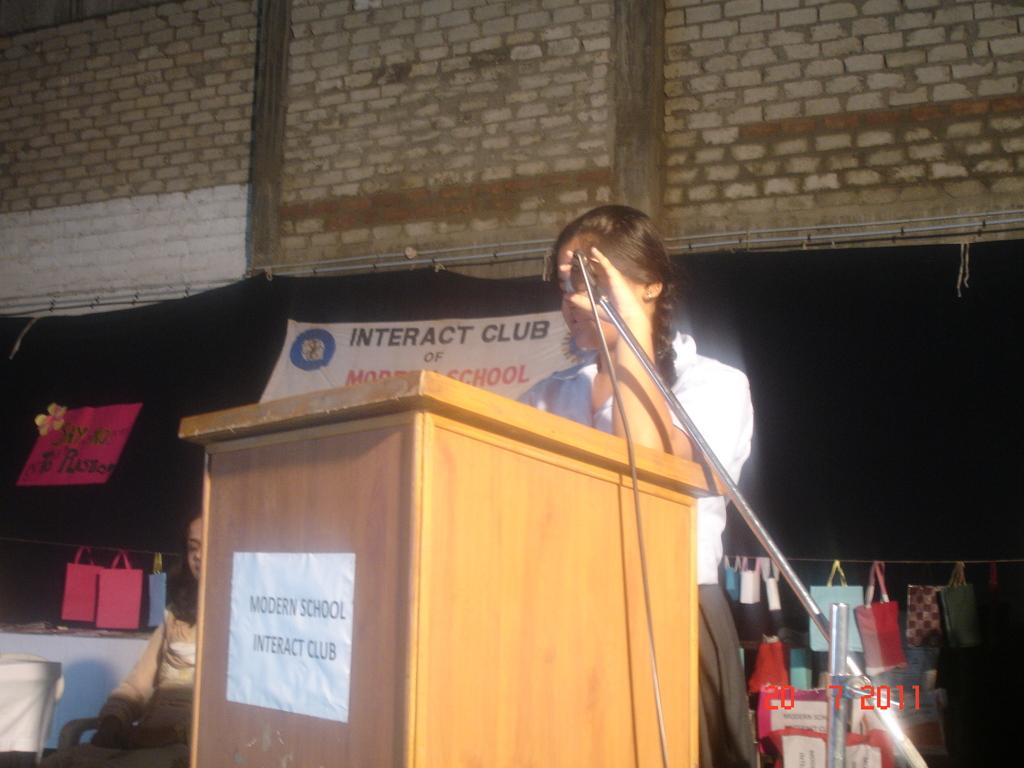Who is the main subject in the image? There is a lady standing in the center of the image. What is the lady holding in her hand? The lady is holding a mic in her hand. What is in front of the lady? There is a podium before her. What can be seen in the background of the image? There are bags and a brick wall in the background of the image. How many dogs are visible in the image? There are no dogs present in the image. What is the lady doing with her feet in the image? The lady's feet are not visible in the image, so it cannot be determined what she is doing with them. 